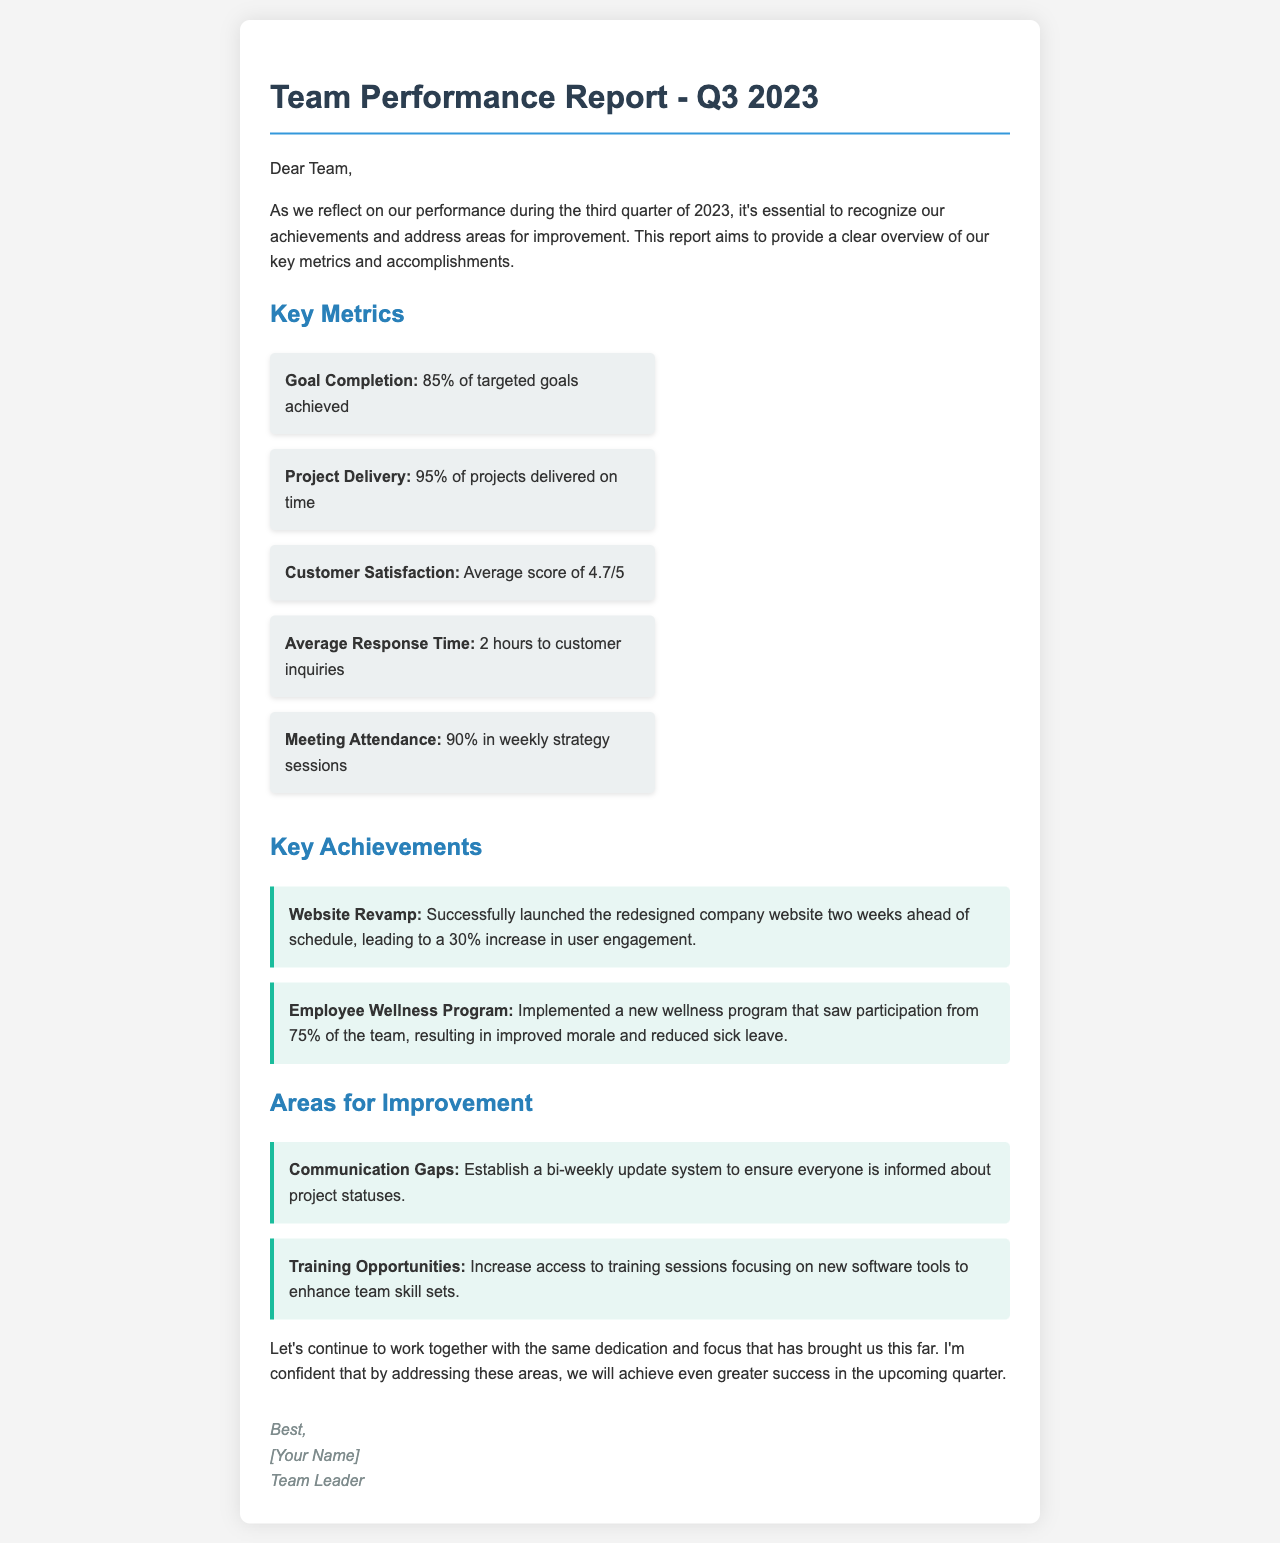What is the goal completion percentage? The goal completion percentage is stated in the report as 85% of targeted goals achieved.
Answer: 85% How many projects were delivered on time? The document mentions that 95% of projects were delivered on time.
Answer: 95% What is the average customer satisfaction score? The average customer satisfaction score is provided as 4.7 out of 5.
Answer: 4.7/5 What improvement is suggested regarding communication? The suggested improvement for communication is to establish a bi-weekly update system.
Answer: Bi-weekly update system What was the participation rate in the employee wellness program? The participation rate in the employee wellness program is indicated as 75% of the team.
Answer: 75% How many hours is the average response time to customer inquiries? The report states that the average response time to customer inquiries is 2 hours.
Answer: 2 hours What was launched ahead of schedule, leading to increased engagement? The document highlights the successful launch of the redesigned company website ahead of schedule.
Answer: Redesigned company website What aspect of team performance is being addressed for improvement? The areas for improvement mentioned are communication gaps and training opportunities.
Answer: Communication gaps and training opportunities How did the team's meeting attendance rate compare to previous periods? The meeting attendance rate is reported as 90% in weekly strategy sessions, showing good engagement.
Answer: 90% 